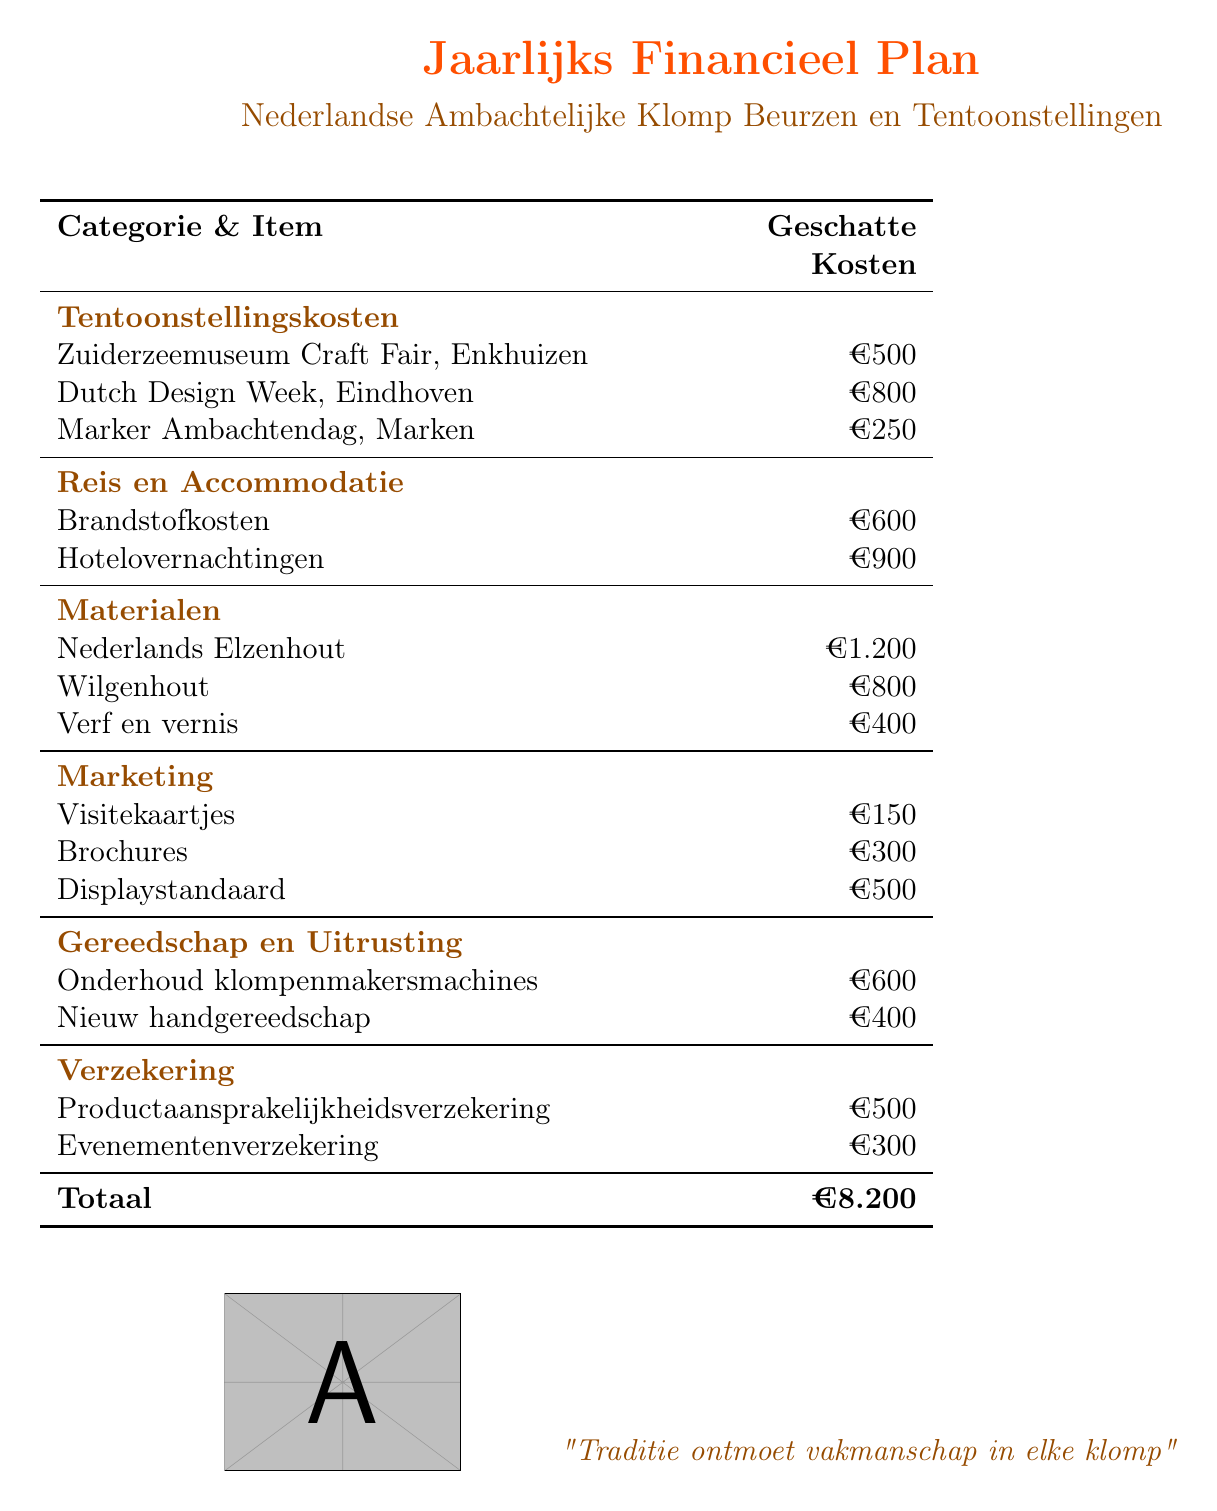what is the total estimated cost? The total estimated cost is the sum of all categories listed in the document, which equals €8,200.
Answer: €8.200 how much is allocated for Dutch Design Week? The document specifies a cost of €800 for participation in the Dutch Design Week.
Answer: €800 what is the cost for hotel accommodations? The hotel overnight expenses are listed in the document as €900.
Answer: €900 which wood type has the highest estimated cost? The document indicates that the highest cost is for Nederlands Elzenhout at €1,200.
Answer: Nederlands Elzenhout how much is spent on marketing materials? The total cost for marketing materials adds up to €950 when summing the costs of visitekaartjes, brochures, and displaystandaard.
Answer: €950 what is the cost for new hand tools? According to the document, the cost for new hand tools is mentioned as €400.
Answer: €400 how many craft fairs are listed in the document? The document lists three craft fairs: Zuiderzeemuseum Craft Fair, Dutch Design Week, and Marker Ambachtendag.
Answer: Three what insurance type costs the most? Productaansprakelijkheidsverzekering is the insurance type listed with the highest cost of €500.
Answer: Productaansprakelijkheidsverzekering how much is budgeted for maintenance of clogs-making machines? The document states that the maintenance cost for klompenmakersmachines is €600.
Answer: €600 